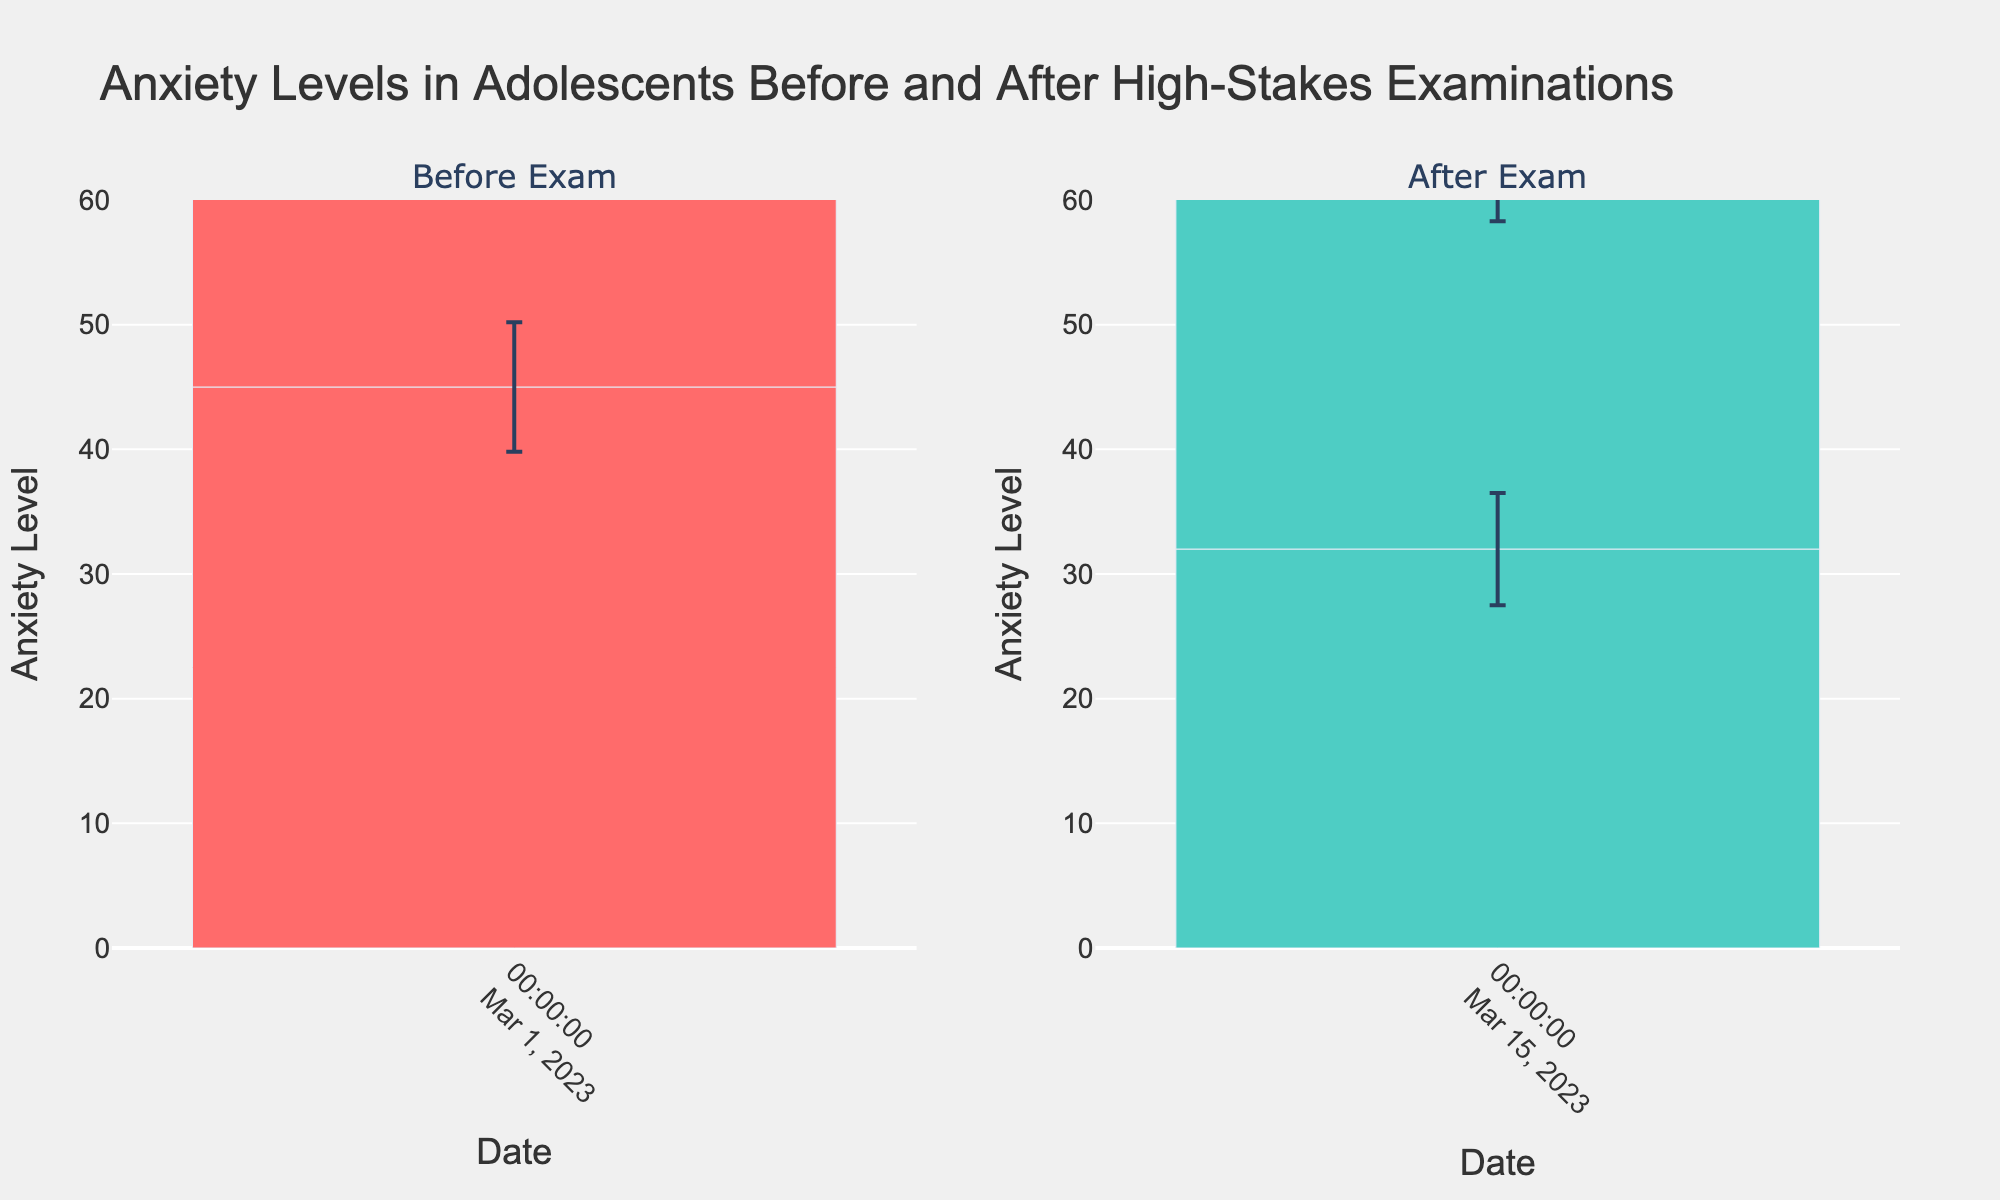What's the title of the figure? The title is prominently placed at the top of the figure and reads "Anxiety Levels in Adolescents Before and After High-Stakes Examinations".
Answer: Anxiety Levels in Adolescents Before and After High-Stakes Examinations What does the y-axis represent in this figure? The y-axis label indicates that it measures the "Anxiety Level".
Answer: Anxiety Level What are the two groups compared in the figure? The subplot titles indicate the two groups compared in the figure: "Before Exam" and "After Exam".
Answer: Before Exam and After Exam What is the range of anxiety levels shown on the y-axis? The y-axis range starts at 0 and goes up to 60, as indicated by the axis labels and tick marks.
Answer: 0 to 60 Which group has a higher average anxiety level? By observing the heights of the bars, the "Before Exam" group has higher average anxiety levels compared to the "After Exam" group.
Answer: Before Exam What's the mean anxiety level for the "Before Exam" group on March 1, 2023? The bars for the "Before Exam" group all represent mean anxiety levels around the mid-40s. By adding the bar heights for March 1, 2023, the approximate average can be calculated. (45 + 47 + 49 + 46) / 4 = 46.75
Answer: 46.75 What is the mean anxiety level for the “After Exam” group? The bars for the "After Exam" group represent mean anxiety levels around the low-30s. (32 + 31 + 33 + 30) / 4 = 31.5
Answer: 31.5 Calculate the difference in mean anxiety levels between the "Before Exam" and the "After Exam" groups. Subtract the mean anxiety level for the "After Exam" group from the "Before Exam" group: 46.75 - 31.5 = 15.25.
Answer: 15.25 Which group shows a greater variation in anxiety levels as indicated by the error bars? The lengths of the error bars indicate variation, and the "Before Exam" group has slightly longer error bars, indicating greater variation.
Answer: Before Exam Is there a noticeable decrease in anxiety levels after the exams? Comparing the bar heights, anxiety levels are significantly lower in the "After Exam" group, showing a noticeable decrease.
Answer: Yes 